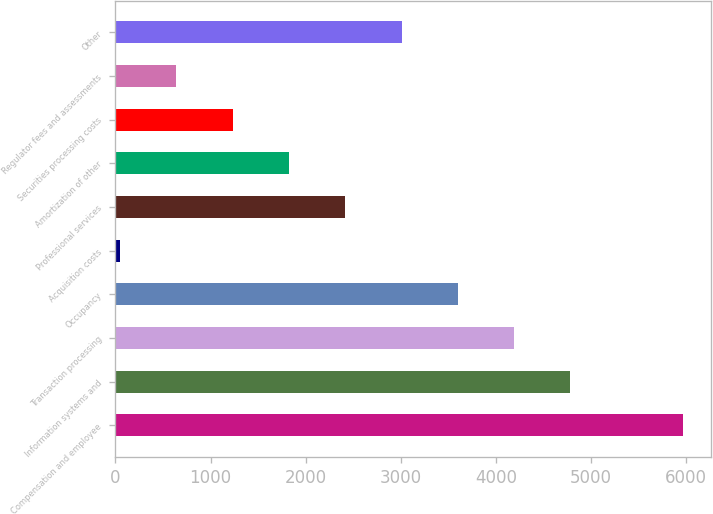<chart> <loc_0><loc_0><loc_500><loc_500><bar_chart><fcel>Compensation and employee<fcel>Information systems and<fcel>Transaction processing<fcel>Occupancy<fcel>Acquisition costs<fcel>Professional services<fcel>Amortization of other<fcel>Securities processing costs<fcel>Regulator fees and assessments<fcel>Other<nl><fcel>5966<fcel>4782.6<fcel>4190.9<fcel>3599.2<fcel>49<fcel>2415.8<fcel>1824.1<fcel>1232.4<fcel>640.7<fcel>3007.5<nl></chart> 